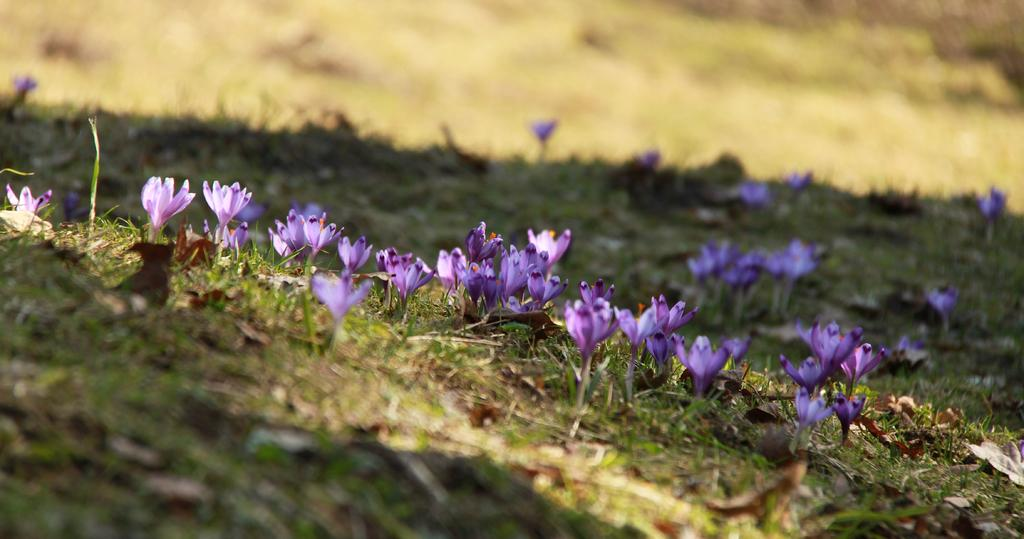What type of flowers can be seen in the image? There are purple color flowers in the image. What type of vegetation is present in the image? There is grass and plants in the image. Can you tell if the image was taken during the day or night? The image was likely taken during the day. What news headline is visible on the flowers in the image? There are no news headlines present in the image; it features flowers, grass, and plants. What type of boundary can be seen in the image? There is no boundary present in the image; it features flowers, grass, and plants. 